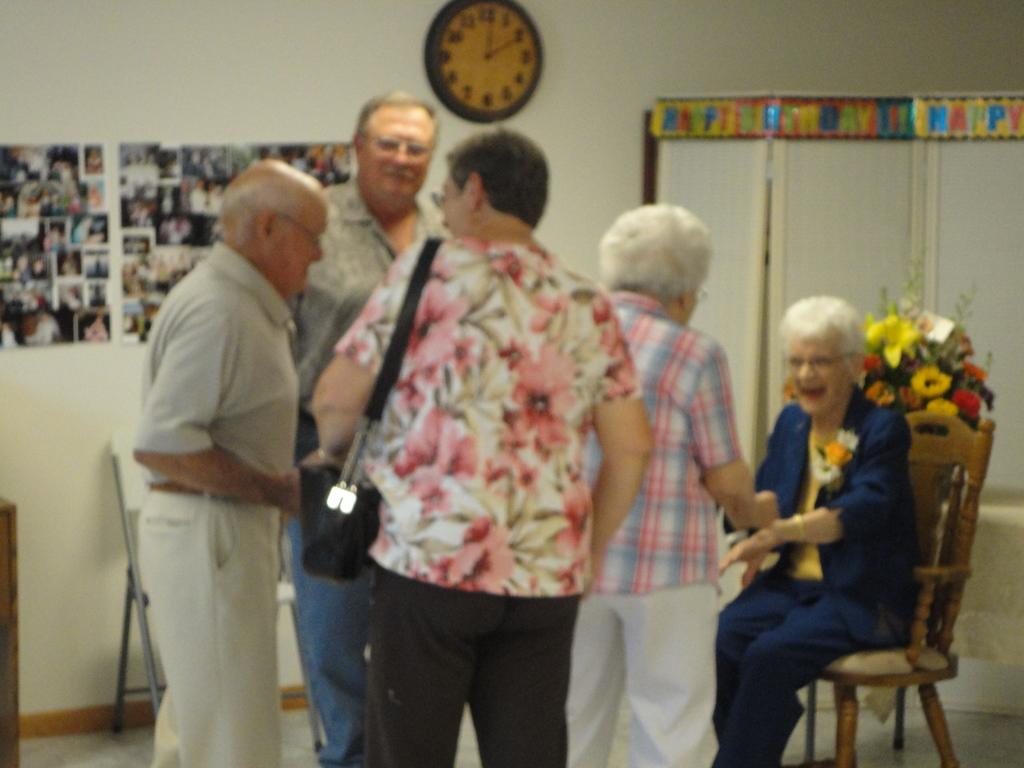How many men are in the picture?
Your response must be concise. Answering does not require reading text in the image. 